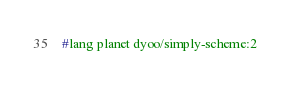<code> <loc_0><loc_0><loc_500><loc_500><_Scheme_>#lang planet dyoo/simply-scheme:2
</code> 